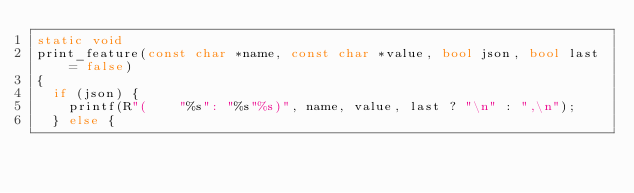Convert code to text. <code><loc_0><loc_0><loc_500><loc_500><_C++_>static void
print_feature(const char *name, const char *value, bool json, bool last = false)
{
  if (json) {
    printf(R"(    "%s": "%s"%s)", name, value, last ? "\n" : ",\n");
  } else {</code> 